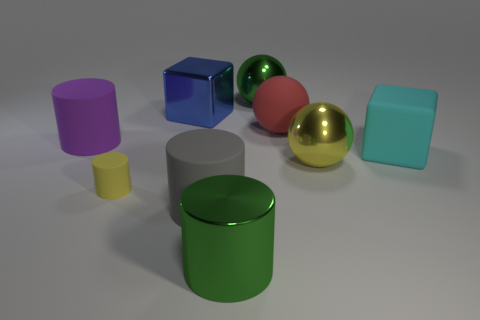Subtract all large shiny balls. How many balls are left? 1 Subtract all yellow balls. How many balls are left? 2 Subtract 2 blocks. How many blocks are left? 0 Subtract all green cylinders. Subtract all red spheres. How many cylinders are left? 3 Subtract all blue spheres. How many gray blocks are left? 0 Subtract 0 yellow cubes. How many objects are left? 9 Subtract all cylinders. How many objects are left? 5 Subtract all cylinders. Subtract all tiny matte cylinders. How many objects are left? 4 Add 8 tiny yellow rubber objects. How many tiny yellow rubber objects are left? 9 Add 9 small red shiny balls. How many small red shiny balls exist? 9 